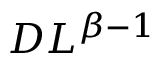Convert formula to latex. <formula><loc_0><loc_0><loc_500><loc_500>D L ^ { \beta - 1 }</formula> 